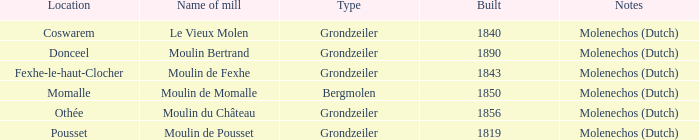What is the denomination of the grondzeiler mill? Le Vieux Molen, Moulin Bertrand, Moulin de Fexhe, Moulin du Château, Moulin de Pousset. 